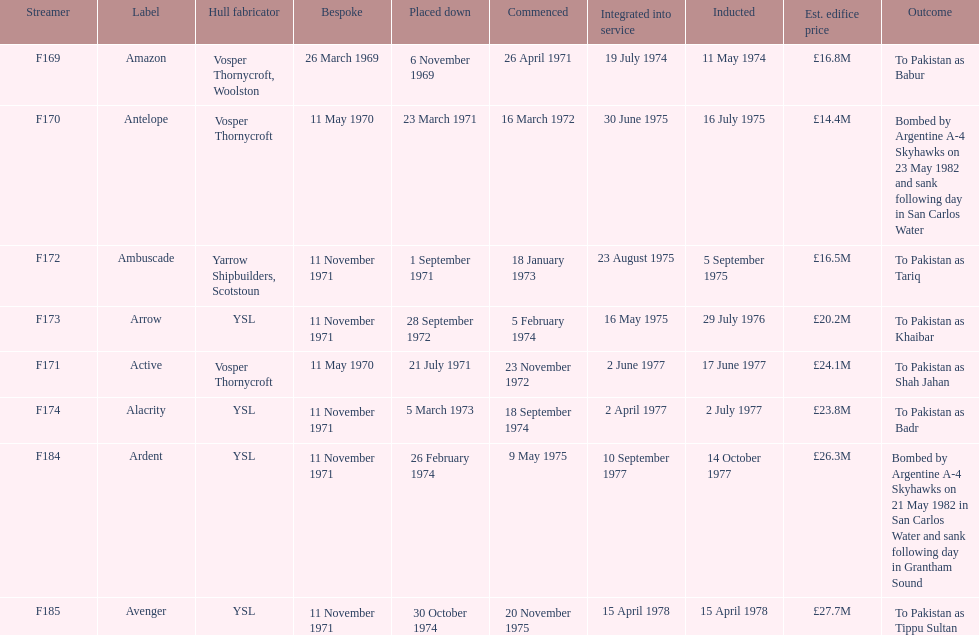How many ships were laid down in september? 2. 